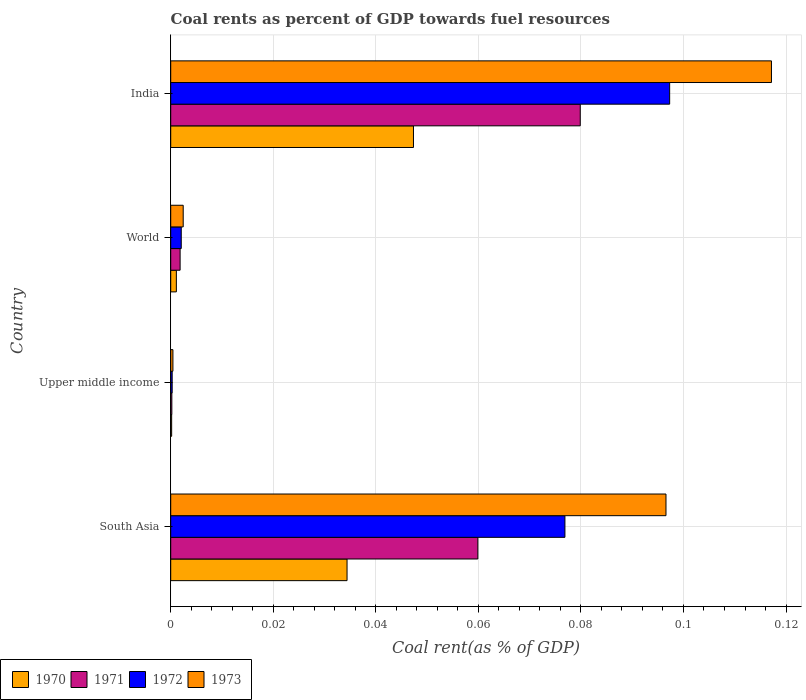How many bars are there on the 1st tick from the bottom?
Your response must be concise. 4. What is the label of the 2nd group of bars from the top?
Provide a succinct answer. World. In how many cases, is the number of bars for a given country not equal to the number of legend labels?
Your response must be concise. 0. What is the coal rent in 1971 in India?
Provide a succinct answer. 0.08. Across all countries, what is the maximum coal rent in 1972?
Provide a succinct answer. 0.1. Across all countries, what is the minimum coal rent in 1970?
Give a very brief answer. 0. In which country was the coal rent in 1970 minimum?
Your answer should be very brief. Upper middle income. What is the total coal rent in 1971 in the graph?
Ensure brevity in your answer.  0.14. What is the difference between the coal rent in 1971 in India and that in Upper middle income?
Offer a terse response. 0.08. What is the difference between the coal rent in 1973 in India and the coal rent in 1970 in Upper middle income?
Your answer should be compact. 0.12. What is the average coal rent in 1973 per country?
Ensure brevity in your answer.  0.05. What is the difference between the coal rent in 1971 and coal rent in 1970 in Upper middle income?
Keep it short and to the point. 3.4968209641675e-5. In how many countries, is the coal rent in 1972 greater than 0.08 %?
Offer a terse response. 1. What is the ratio of the coal rent in 1971 in Upper middle income to that in World?
Keep it short and to the point. 0.12. What is the difference between the highest and the second highest coal rent in 1970?
Offer a very short reply. 0.01. What is the difference between the highest and the lowest coal rent in 1972?
Ensure brevity in your answer.  0.1. Is it the case that in every country, the sum of the coal rent in 1970 and coal rent in 1971 is greater than the sum of coal rent in 1972 and coal rent in 1973?
Provide a short and direct response. No. Are all the bars in the graph horizontal?
Make the answer very short. Yes. What is the difference between two consecutive major ticks on the X-axis?
Provide a succinct answer. 0.02. Are the values on the major ticks of X-axis written in scientific E-notation?
Make the answer very short. No. Does the graph contain any zero values?
Your answer should be compact. No. Where does the legend appear in the graph?
Keep it short and to the point. Bottom left. What is the title of the graph?
Keep it short and to the point. Coal rents as percent of GDP towards fuel resources. What is the label or title of the X-axis?
Keep it short and to the point. Coal rent(as % of GDP). What is the label or title of the Y-axis?
Give a very brief answer. Country. What is the Coal rent(as % of GDP) in 1970 in South Asia?
Your answer should be very brief. 0.03. What is the Coal rent(as % of GDP) in 1971 in South Asia?
Keep it short and to the point. 0.06. What is the Coal rent(as % of GDP) in 1972 in South Asia?
Provide a short and direct response. 0.08. What is the Coal rent(as % of GDP) of 1973 in South Asia?
Give a very brief answer. 0.1. What is the Coal rent(as % of GDP) in 1970 in Upper middle income?
Make the answer very short. 0. What is the Coal rent(as % of GDP) in 1971 in Upper middle income?
Provide a succinct answer. 0. What is the Coal rent(as % of GDP) in 1972 in Upper middle income?
Offer a very short reply. 0. What is the Coal rent(as % of GDP) of 1973 in Upper middle income?
Give a very brief answer. 0. What is the Coal rent(as % of GDP) of 1970 in World?
Make the answer very short. 0. What is the Coal rent(as % of GDP) of 1971 in World?
Provide a succinct answer. 0. What is the Coal rent(as % of GDP) in 1972 in World?
Provide a short and direct response. 0. What is the Coal rent(as % of GDP) of 1973 in World?
Make the answer very short. 0. What is the Coal rent(as % of GDP) in 1970 in India?
Provide a succinct answer. 0.05. What is the Coal rent(as % of GDP) of 1971 in India?
Your response must be concise. 0.08. What is the Coal rent(as % of GDP) of 1972 in India?
Make the answer very short. 0.1. What is the Coal rent(as % of GDP) in 1973 in India?
Provide a succinct answer. 0.12. Across all countries, what is the maximum Coal rent(as % of GDP) in 1970?
Provide a short and direct response. 0.05. Across all countries, what is the maximum Coal rent(as % of GDP) in 1971?
Provide a succinct answer. 0.08. Across all countries, what is the maximum Coal rent(as % of GDP) in 1972?
Provide a succinct answer. 0.1. Across all countries, what is the maximum Coal rent(as % of GDP) in 1973?
Offer a very short reply. 0.12. Across all countries, what is the minimum Coal rent(as % of GDP) in 1970?
Ensure brevity in your answer.  0. Across all countries, what is the minimum Coal rent(as % of GDP) in 1971?
Ensure brevity in your answer.  0. Across all countries, what is the minimum Coal rent(as % of GDP) of 1972?
Give a very brief answer. 0. Across all countries, what is the minimum Coal rent(as % of GDP) in 1973?
Your answer should be very brief. 0. What is the total Coal rent(as % of GDP) of 1970 in the graph?
Offer a terse response. 0.08. What is the total Coal rent(as % of GDP) of 1971 in the graph?
Offer a terse response. 0.14. What is the total Coal rent(as % of GDP) of 1972 in the graph?
Provide a succinct answer. 0.18. What is the total Coal rent(as % of GDP) of 1973 in the graph?
Make the answer very short. 0.22. What is the difference between the Coal rent(as % of GDP) in 1970 in South Asia and that in Upper middle income?
Provide a short and direct response. 0.03. What is the difference between the Coal rent(as % of GDP) in 1971 in South Asia and that in Upper middle income?
Make the answer very short. 0.06. What is the difference between the Coal rent(as % of GDP) of 1972 in South Asia and that in Upper middle income?
Make the answer very short. 0.08. What is the difference between the Coal rent(as % of GDP) in 1973 in South Asia and that in Upper middle income?
Ensure brevity in your answer.  0.1. What is the difference between the Coal rent(as % of GDP) of 1971 in South Asia and that in World?
Provide a short and direct response. 0.06. What is the difference between the Coal rent(as % of GDP) of 1972 in South Asia and that in World?
Make the answer very short. 0.07. What is the difference between the Coal rent(as % of GDP) in 1973 in South Asia and that in World?
Keep it short and to the point. 0.09. What is the difference between the Coal rent(as % of GDP) of 1970 in South Asia and that in India?
Make the answer very short. -0.01. What is the difference between the Coal rent(as % of GDP) in 1971 in South Asia and that in India?
Offer a terse response. -0.02. What is the difference between the Coal rent(as % of GDP) of 1972 in South Asia and that in India?
Your answer should be very brief. -0.02. What is the difference between the Coal rent(as % of GDP) in 1973 in South Asia and that in India?
Your answer should be very brief. -0.02. What is the difference between the Coal rent(as % of GDP) of 1970 in Upper middle income and that in World?
Ensure brevity in your answer.  -0. What is the difference between the Coal rent(as % of GDP) of 1971 in Upper middle income and that in World?
Your response must be concise. -0. What is the difference between the Coal rent(as % of GDP) of 1972 in Upper middle income and that in World?
Your response must be concise. -0. What is the difference between the Coal rent(as % of GDP) of 1973 in Upper middle income and that in World?
Your answer should be very brief. -0. What is the difference between the Coal rent(as % of GDP) of 1970 in Upper middle income and that in India?
Provide a succinct answer. -0.05. What is the difference between the Coal rent(as % of GDP) in 1971 in Upper middle income and that in India?
Provide a short and direct response. -0.08. What is the difference between the Coal rent(as % of GDP) of 1972 in Upper middle income and that in India?
Your answer should be very brief. -0.1. What is the difference between the Coal rent(as % of GDP) of 1973 in Upper middle income and that in India?
Offer a very short reply. -0.12. What is the difference between the Coal rent(as % of GDP) in 1970 in World and that in India?
Keep it short and to the point. -0.05. What is the difference between the Coal rent(as % of GDP) of 1971 in World and that in India?
Ensure brevity in your answer.  -0.08. What is the difference between the Coal rent(as % of GDP) in 1972 in World and that in India?
Make the answer very short. -0.1. What is the difference between the Coal rent(as % of GDP) in 1973 in World and that in India?
Provide a succinct answer. -0.11. What is the difference between the Coal rent(as % of GDP) of 1970 in South Asia and the Coal rent(as % of GDP) of 1971 in Upper middle income?
Provide a short and direct response. 0.03. What is the difference between the Coal rent(as % of GDP) in 1970 in South Asia and the Coal rent(as % of GDP) in 1972 in Upper middle income?
Your response must be concise. 0.03. What is the difference between the Coal rent(as % of GDP) in 1970 in South Asia and the Coal rent(as % of GDP) in 1973 in Upper middle income?
Offer a terse response. 0.03. What is the difference between the Coal rent(as % of GDP) in 1971 in South Asia and the Coal rent(as % of GDP) in 1972 in Upper middle income?
Provide a short and direct response. 0.06. What is the difference between the Coal rent(as % of GDP) of 1971 in South Asia and the Coal rent(as % of GDP) of 1973 in Upper middle income?
Offer a terse response. 0.06. What is the difference between the Coal rent(as % of GDP) in 1972 in South Asia and the Coal rent(as % of GDP) in 1973 in Upper middle income?
Ensure brevity in your answer.  0.08. What is the difference between the Coal rent(as % of GDP) of 1970 in South Asia and the Coal rent(as % of GDP) of 1971 in World?
Provide a succinct answer. 0.03. What is the difference between the Coal rent(as % of GDP) of 1970 in South Asia and the Coal rent(as % of GDP) of 1972 in World?
Make the answer very short. 0.03. What is the difference between the Coal rent(as % of GDP) in 1970 in South Asia and the Coal rent(as % of GDP) in 1973 in World?
Keep it short and to the point. 0.03. What is the difference between the Coal rent(as % of GDP) in 1971 in South Asia and the Coal rent(as % of GDP) in 1972 in World?
Keep it short and to the point. 0.06. What is the difference between the Coal rent(as % of GDP) in 1971 in South Asia and the Coal rent(as % of GDP) in 1973 in World?
Your answer should be very brief. 0.06. What is the difference between the Coal rent(as % of GDP) of 1972 in South Asia and the Coal rent(as % of GDP) of 1973 in World?
Your answer should be very brief. 0.07. What is the difference between the Coal rent(as % of GDP) in 1970 in South Asia and the Coal rent(as % of GDP) in 1971 in India?
Make the answer very short. -0.05. What is the difference between the Coal rent(as % of GDP) in 1970 in South Asia and the Coal rent(as % of GDP) in 1972 in India?
Provide a succinct answer. -0.06. What is the difference between the Coal rent(as % of GDP) of 1970 in South Asia and the Coal rent(as % of GDP) of 1973 in India?
Your answer should be compact. -0.08. What is the difference between the Coal rent(as % of GDP) of 1971 in South Asia and the Coal rent(as % of GDP) of 1972 in India?
Offer a terse response. -0.04. What is the difference between the Coal rent(as % of GDP) of 1971 in South Asia and the Coal rent(as % of GDP) of 1973 in India?
Offer a terse response. -0.06. What is the difference between the Coal rent(as % of GDP) of 1972 in South Asia and the Coal rent(as % of GDP) of 1973 in India?
Ensure brevity in your answer.  -0.04. What is the difference between the Coal rent(as % of GDP) in 1970 in Upper middle income and the Coal rent(as % of GDP) in 1971 in World?
Make the answer very short. -0. What is the difference between the Coal rent(as % of GDP) in 1970 in Upper middle income and the Coal rent(as % of GDP) in 1972 in World?
Provide a short and direct response. -0. What is the difference between the Coal rent(as % of GDP) in 1970 in Upper middle income and the Coal rent(as % of GDP) in 1973 in World?
Offer a very short reply. -0. What is the difference between the Coal rent(as % of GDP) in 1971 in Upper middle income and the Coal rent(as % of GDP) in 1972 in World?
Your answer should be compact. -0. What is the difference between the Coal rent(as % of GDP) in 1971 in Upper middle income and the Coal rent(as % of GDP) in 1973 in World?
Offer a terse response. -0. What is the difference between the Coal rent(as % of GDP) in 1972 in Upper middle income and the Coal rent(as % of GDP) in 1973 in World?
Provide a short and direct response. -0. What is the difference between the Coal rent(as % of GDP) of 1970 in Upper middle income and the Coal rent(as % of GDP) of 1971 in India?
Offer a very short reply. -0.08. What is the difference between the Coal rent(as % of GDP) in 1970 in Upper middle income and the Coal rent(as % of GDP) in 1972 in India?
Keep it short and to the point. -0.1. What is the difference between the Coal rent(as % of GDP) of 1970 in Upper middle income and the Coal rent(as % of GDP) of 1973 in India?
Provide a succinct answer. -0.12. What is the difference between the Coal rent(as % of GDP) in 1971 in Upper middle income and the Coal rent(as % of GDP) in 1972 in India?
Your answer should be very brief. -0.1. What is the difference between the Coal rent(as % of GDP) in 1971 in Upper middle income and the Coal rent(as % of GDP) in 1973 in India?
Give a very brief answer. -0.12. What is the difference between the Coal rent(as % of GDP) of 1972 in Upper middle income and the Coal rent(as % of GDP) of 1973 in India?
Your answer should be very brief. -0.12. What is the difference between the Coal rent(as % of GDP) in 1970 in World and the Coal rent(as % of GDP) in 1971 in India?
Offer a very short reply. -0.08. What is the difference between the Coal rent(as % of GDP) in 1970 in World and the Coal rent(as % of GDP) in 1972 in India?
Provide a succinct answer. -0.1. What is the difference between the Coal rent(as % of GDP) of 1970 in World and the Coal rent(as % of GDP) of 1973 in India?
Ensure brevity in your answer.  -0.12. What is the difference between the Coal rent(as % of GDP) in 1971 in World and the Coal rent(as % of GDP) in 1972 in India?
Ensure brevity in your answer.  -0.1. What is the difference between the Coal rent(as % of GDP) of 1971 in World and the Coal rent(as % of GDP) of 1973 in India?
Your answer should be compact. -0.12. What is the difference between the Coal rent(as % of GDP) in 1972 in World and the Coal rent(as % of GDP) in 1973 in India?
Offer a terse response. -0.12. What is the average Coal rent(as % of GDP) of 1970 per country?
Give a very brief answer. 0.02. What is the average Coal rent(as % of GDP) in 1971 per country?
Offer a very short reply. 0.04. What is the average Coal rent(as % of GDP) of 1972 per country?
Keep it short and to the point. 0.04. What is the average Coal rent(as % of GDP) in 1973 per country?
Provide a short and direct response. 0.05. What is the difference between the Coal rent(as % of GDP) of 1970 and Coal rent(as % of GDP) of 1971 in South Asia?
Your answer should be compact. -0.03. What is the difference between the Coal rent(as % of GDP) of 1970 and Coal rent(as % of GDP) of 1972 in South Asia?
Ensure brevity in your answer.  -0.04. What is the difference between the Coal rent(as % of GDP) of 1970 and Coal rent(as % of GDP) of 1973 in South Asia?
Give a very brief answer. -0.06. What is the difference between the Coal rent(as % of GDP) in 1971 and Coal rent(as % of GDP) in 1972 in South Asia?
Your answer should be compact. -0.02. What is the difference between the Coal rent(as % of GDP) in 1971 and Coal rent(as % of GDP) in 1973 in South Asia?
Your answer should be very brief. -0.04. What is the difference between the Coal rent(as % of GDP) in 1972 and Coal rent(as % of GDP) in 1973 in South Asia?
Keep it short and to the point. -0.02. What is the difference between the Coal rent(as % of GDP) of 1970 and Coal rent(as % of GDP) of 1971 in Upper middle income?
Offer a very short reply. -0. What is the difference between the Coal rent(as % of GDP) of 1970 and Coal rent(as % of GDP) of 1972 in Upper middle income?
Offer a very short reply. -0. What is the difference between the Coal rent(as % of GDP) in 1970 and Coal rent(as % of GDP) in 1973 in Upper middle income?
Your response must be concise. -0. What is the difference between the Coal rent(as % of GDP) of 1971 and Coal rent(as % of GDP) of 1972 in Upper middle income?
Give a very brief answer. -0. What is the difference between the Coal rent(as % of GDP) of 1971 and Coal rent(as % of GDP) of 1973 in Upper middle income?
Your response must be concise. -0. What is the difference between the Coal rent(as % of GDP) of 1972 and Coal rent(as % of GDP) of 1973 in Upper middle income?
Keep it short and to the point. -0. What is the difference between the Coal rent(as % of GDP) in 1970 and Coal rent(as % of GDP) in 1971 in World?
Give a very brief answer. -0. What is the difference between the Coal rent(as % of GDP) in 1970 and Coal rent(as % of GDP) in 1972 in World?
Provide a succinct answer. -0. What is the difference between the Coal rent(as % of GDP) in 1970 and Coal rent(as % of GDP) in 1973 in World?
Keep it short and to the point. -0. What is the difference between the Coal rent(as % of GDP) of 1971 and Coal rent(as % of GDP) of 1972 in World?
Give a very brief answer. -0. What is the difference between the Coal rent(as % of GDP) in 1971 and Coal rent(as % of GDP) in 1973 in World?
Give a very brief answer. -0. What is the difference between the Coal rent(as % of GDP) of 1972 and Coal rent(as % of GDP) of 1973 in World?
Your response must be concise. -0. What is the difference between the Coal rent(as % of GDP) of 1970 and Coal rent(as % of GDP) of 1971 in India?
Your answer should be very brief. -0.03. What is the difference between the Coal rent(as % of GDP) in 1970 and Coal rent(as % of GDP) in 1972 in India?
Ensure brevity in your answer.  -0.05. What is the difference between the Coal rent(as % of GDP) of 1970 and Coal rent(as % of GDP) of 1973 in India?
Make the answer very short. -0.07. What is the difference between the Coal rent(as % of GDP) of 1971 and Coal rent(as % of GDP) of 1972 in India?
Your answer should be compact. -0.02. What is the difference between the Coal rent(as % of GDP) of 1971 and Coal rent(as % of GDP) of 1973 in India?
Your answer should be very brief. -0.04. What is the difference between the Coal rent(as % of GDP) of 1972 and Coal rent(as % of GDP) of 1973 in India?
Provide a short and direct response. -0.02. What is the ratio of the Coal rent(as % of GDP) in 1970 in South Asia to that in Upper middle income?
Make the answer very short. 187.05. What is the ratio of the Coal rent(as % of GDP) of 1971 in South Asia to that in Upper middle income?
Your answer should be very brief. 273.74. What is the ratio of the Coal rent(as % of GDP) in 1972 in South Asia to that in Upper middle income?
Your answer should be compact. 270.32. What is the ratio of the Coal rent(as % of GDP) of 1973 in South Asia to that in Upper middle income?
Offer a very short reply. 224.18. What is the ratio of the Coal rent(as % of GDP) in 1970 in South Asia to that in World?
Your response must be concise. 31.24. What is the ratio of the Coal rent(as % of GDP) in 1971 in South Asia to that in World?
Keep it short and to the point. 32.69. What is the ratio of the Coal rent(as % of GDP) of 1972 in South Asia to that in World?
Provide a short and direct response. 37.41. What is the ratio of the Coal rent(as % of GDP) in 1973 in South Asia to that in World?
Provide a short and direct response. 39.65. What is the ratio of the Coal rent(as % of GDP) of 1970 in South Asia to that in India?
Provide a succinct answer. 0.73. What is the ratio of the Coal rent(as % of GDP) in 1971 in South Asia to that in India?
Provide a short and direct response. 0.75. What is the ratio of the Coal rent(as % of GDP) in 1972 in South Asia to that in India?
Your response must be concise. 0.79. What is the ratio of the Coal rent(as % of GDP) of 1973 in South Asia to that in India?
Your answer should be compact. 0.82. What is the ratio of the Coal rent(as % of GDP) in 1970 in Upper middle income to that in World?
Offer a very short reply. 0.17. What is the ratio of the Coal rent(as % of GDP) of 1971 in Upper middle income to that in World?
Make the answer very short. 0.12. What is the ratio of the Coal rent(as % of GDP) in 1972 in Upper middle income to that in World?
Give a very brief answer. 0.14. What is the ratio of the Coal rent(as % of GDP) of 1973 in Upper middle income to that in World?
Offer a terse response. 0.18. What is the ratio of the Coal rent(as % of GDP) in 1970 in Upper middle income to that in India?
Your answer should be compact. 0. What is the ratio of the Coal rent(as % of GDP) of 1971 in Upper middle income to that in India?
Ensure brevity in your answer.  0. What is the ratio of the Coal rent(as % of GDP) in 1972 in Upper middle income to that in India?
Your answer should be very brief. 0. What is the ratio of the Coal rent(as % of GDP) of 1973 in Upper middle income to that in India?
Keep it short and to the point. 0. What is the ratio of the Coal rent(as % of GDP) in 1970 in World to that in India?
Offer a very short reply. 0.02. What is the ratio of the Coal rent(as % of GDP) of 1971 in World to that in India?
Provide a short and direct response. 0.02. What is the ratio of the Coal rent(as % of GDP) of 1972 in World to that in India?
Make the answer very short. 0.02. What is the ratio of the Coal rent(as % of GDP) of 1973 in World to that in India?
Keep it short and to the point. 0.02. What is the difference between the highest and the second highest Coal rent(as % of GDP) of 1970?
Provide a short and direct response. 0.01. What is the difference between the highest and the second highest Coal rent(as % of GDP) of 1972?
Provide a succinct answer. 0.02. What is the difference between the highest and the second highest Coal rent(as % of GDP) of 1973?
Provide a succinct answer. 0.02. What is the difference between the highest and the lowest Coal rent(as % of GDP) in 1970?
Provide a succinct answer. 0.05. What is the difference between the highest and the lowest Coal rent(as % of GDP) of 1971?
Provide a short and direct response. 0.08. What is the difference between the highest and the lowest Coal rent(as % of GDP) in 1972?
Offer a very short reply. 0.1. What is the difference between the highest and the lowest Coal rent(as % of GDP) of 1973?
Offer a terse response. 0.12. 